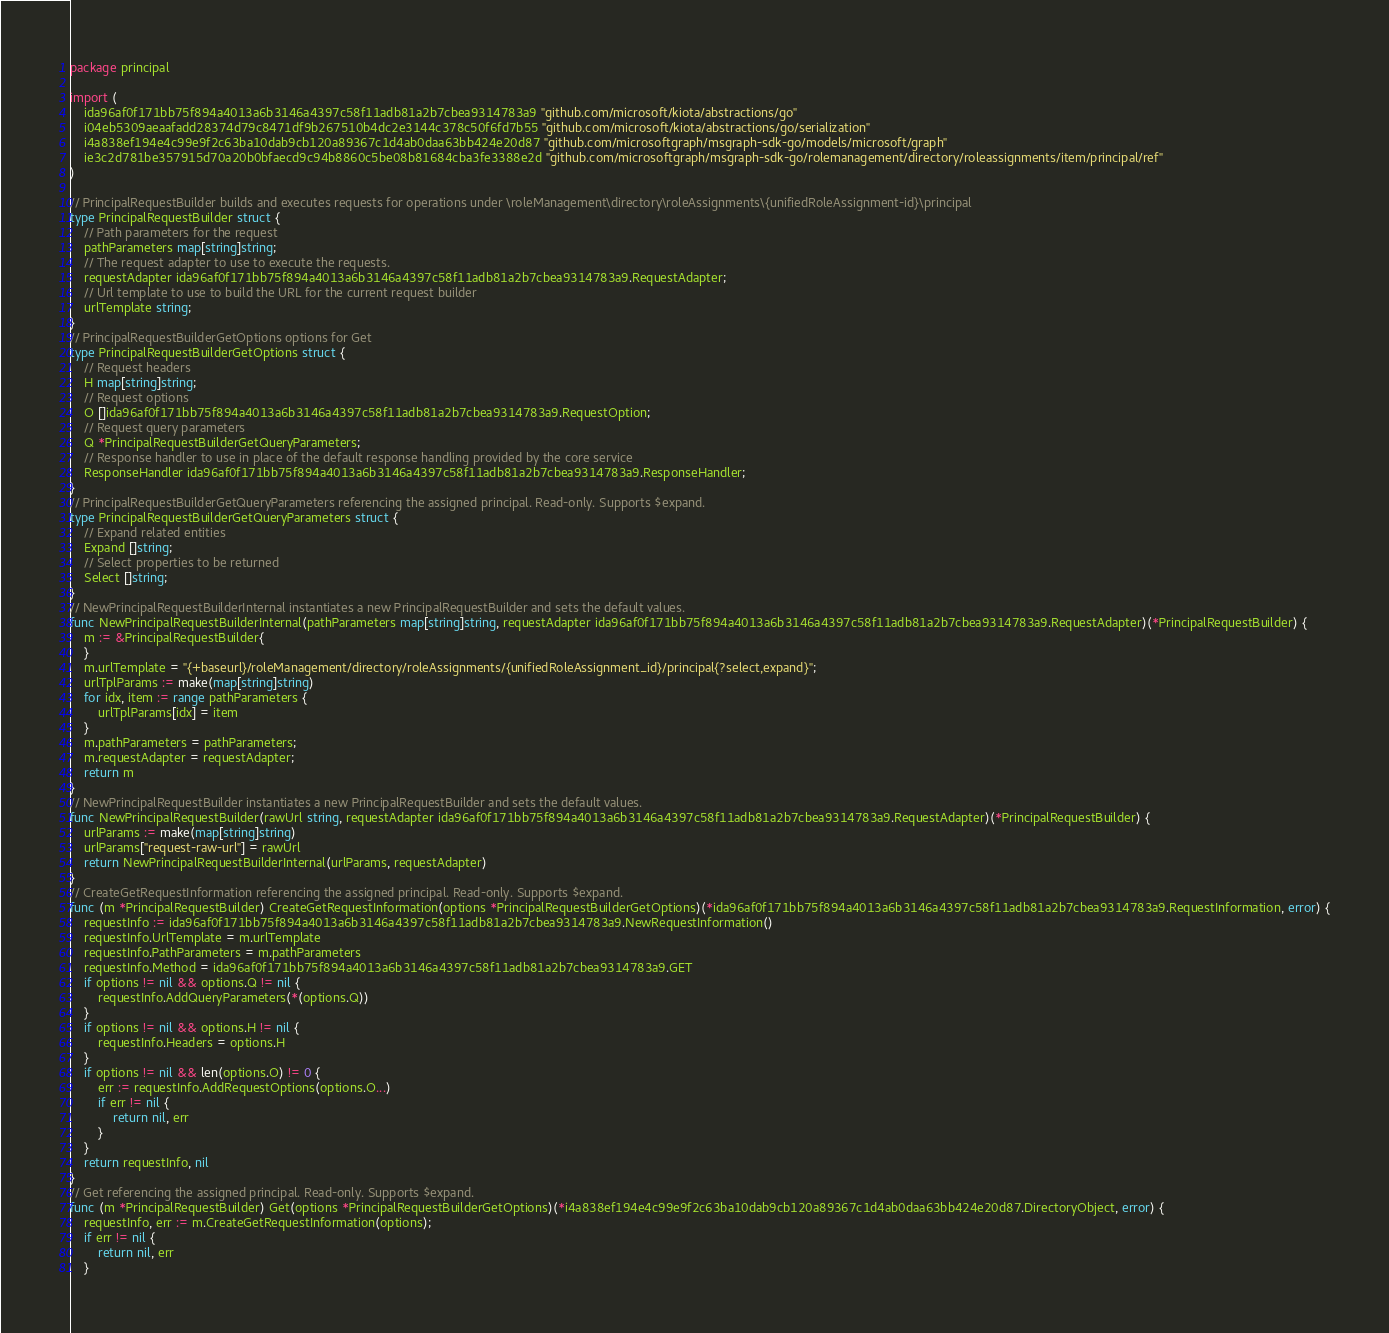Convert code to text. <code><loc_0><loc_0><loc_500><loc_500><_Go_>package principal

import (
    ida96af0f171bb75f894a4013a6b3146a4397c58f11adb81a2b7cbea9314783a9 "github.com/microsoft/kiota/abstractions/go"
    i04eb5309aeaafadd28374d79c8471df9b267510b4dc2e3144c378c50f6fd7b55 "github.com/microsoft/kiota/abstractions/go/serialization"
    i4a838ef194e4c99e9f2c63ba10dab9cb120a89367c1d4ab0daa63bb424e20d87 "github.com/microsoftgraph/msgraph-sdk-go/models/microsoft/graph"
    ie3c2d781be357915d70a20b0bfaecd9c94b8860c5be08b81684cba3fe3388e2d "github.com/microsoftgraph/msgraph-sdk-go/rolemanagement/directory/roleassignments/item/principal/ref"
)

// PrincipalRequestBuilder builds and executes requests for operations under \roleManagement\directory\roleAssignments\{unifiedRoleAssignment-id}\principal
type PrincipalRequestBuilder struct {
    // Path parameters for the request
    pathParameters map[string]string;
    // The request adapter to use to execute the requests.
    requestAdapter ida96af0f171bb75f894a4013a6b3146a4397c58f11adb81a2b7cbea9314783a9.RequestAdapter;
    // Url template to use to build the URL for the current request builder
    urlTemplate string;
}
// PrincipalRequestBuilderGetOptions options for Get
type PrincipalRequestBuilderGetOptions struct {
    // Request headers
    H map[string]string;
    // Request options
    O []ida96af0f171bb75f894a4013a6b3146a4397c58f11adb81a2b7cbea9314783a9.RequestOption;
    // Request query parameters
    Q *PrincipalRequestBuilderGetQueryParameters;
    // Response handler to use in place of the default response handling provided by the core service
    ResponseHandler ida96af0f171bb75f894a4013a6b3146a4397c58f11adb81a2b7cbea9314783a9.ResponseHandler;
}
// PrincipalRequestBuilderGetQueryParameters referencing the assigned principal. Read-only. Supports $expand.
type PrincipalRequestBuilderGetQueryParameters struct {
    // Expand related entities
    Expand []string;
    // Select properties to be returned
    Select []string;
}
// NewPrincipalRequestBuilderInternal instantiates a new PrincipalRequestBuilder and sets the default values.
func NewPrincipalRequestBuilderInternal(pathParameters map[string]string, requestAdapter ida96af0f171bb75f894a4013a6b3146a4397c58f11adb81a2b7cbea9314783a9.RequestAdapter)(*PrincipalRequestBuilder) {
    m := &PrincipalRequestBuilder{
    }
    m.urlTemplate = "{+baseurl}/roleManagement/directory/roleAssignments/{unifiedRoleAssignment_id}/principal{?select,expand}";
    urlTplParams := make(map[string]string)
    for idx, item := range pathParameters {
        urlTplParams[idx] = item
    }
    m.pathParameters = pathParameters;
    m.requestAdapter = requestAdapter;
    return m
}
// NewPrincipalRequestBuilder instantiates a new PrincipalRequestBuilder and sets the default values.
func NewPrincipalRequestBuilder(rawUrl string, requestAdapter ida96af0f171bb75f894a4013a6b3146a4397c58f11adb81a2b7cbea9314783a9.RequestAdapter)(*PrincipalRequestBuilder) {
    urlParams := make(map[string]string)
    urlParams["request-raw-url"] = rawUrl
    return NewPrincipalRequestBuilderInternal(urlParams, requestAdapter)
}
// CreateGetRequestInformation referencing the assigned principal. Read-only. Supports $expand.
func (m *PrincipalRequestBuilder) CreateGetRequestInformation(options *PrincipalRequestBuilderGetOptions)(*ida96af0f171bb75f894a4013a6b3146a4397c58f11adb81a2b7cbea9314783a9.RequestInformation, error) {
    requestInfo := ida96af0f171bb75f894a4013a6b3146a4397c58f11adb81a2b7cbea9314783a9.NewRequestInformation()
    requestInfo.UrlTemplate = m.urlTemplate
    requestInfo.PathParameters = m.pathParameters
    requestInfo.Method = ida96af0f171bb75f894a4013a6b3146a4397c58f11adb81a2b7cbea9314783a9.GET
    if options != nil && options.Q != nil {
        requestInfo.AddQueryParameters(*(options.Q))
    }
    if options != nil && options.H != nil {
        requestInfo.Headers = options.H
    }
    if options != nil && len(options.O) != 0 {
        err := requestInfo.AddRequestOptions(options.O...)
        if err != nil {
            return nil, err
        }
    }
    return requestInfo, nil
}
// Get referencing the assigned principal. Read-only. Supports $expand.
func (m *PrincipalRequestBuilder) Get(options *PrincipalRequestBuilderGetOptions)(*i4a838ef194e4c99e9f2c63ba10dab9cb120a89367c1d4ab0daa63bb424e20d87.DirectoryObject, error) {
    requestInfo, err := m.CreateGetRequestInformation(options);
    if err != nil {
        return nil, err
    }</code> 